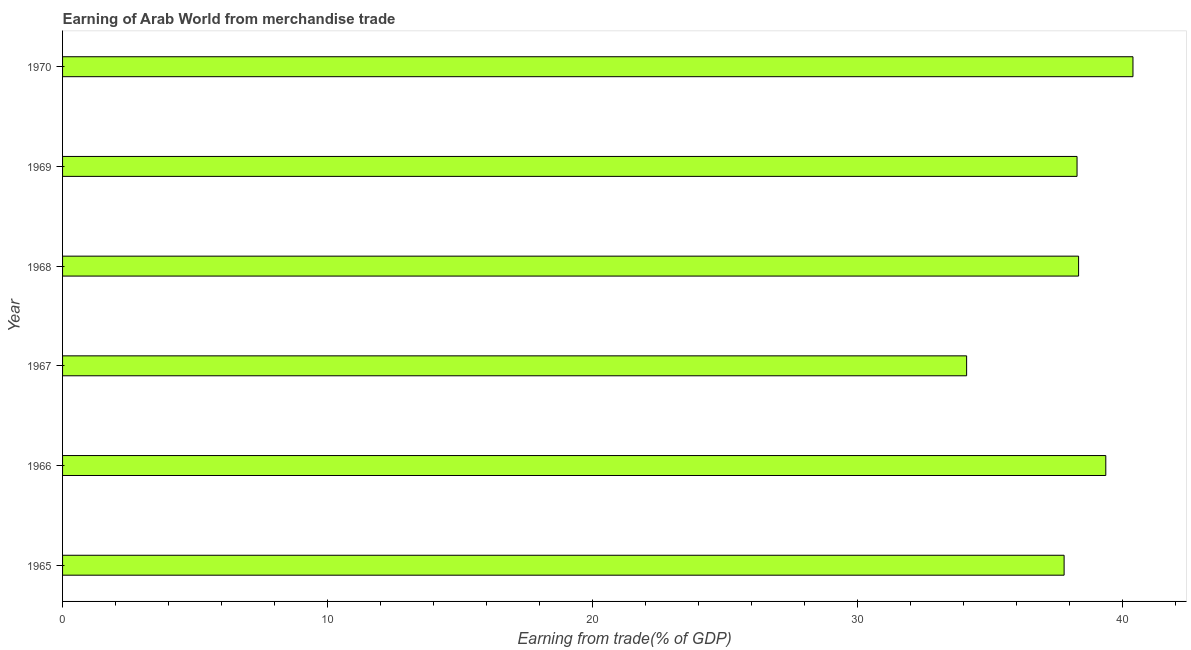Does the graph contain any zero values?
Offer a terse response. No. Does the graph contain grids?
Make the answer very short. No. What is the title of the graph?
Provide a succinct answer. Earning of Arab World from merchandise trade. What is the label or title of the X-axis?
Your answer should be compact. Earning from trade(% of GDP). What is the label or title of the Y-axis?
Your answer should be very brief. Year. What is the earning from merchandise trade in 1966?
Give a very brief answer. 39.38. Across all years, what is the maximum earning from merchandise trade?
Ensure brevity in your answer.  40.4. Across all years, what is the minimum earning from merchandise trade?
Provide a short and direct response. 34.12. In which year was the earning from merchandise trade maximum?
Your answer should be very brief. 1970. In which year was the earning from merchandise trade minimum?
Provide a succinct answer. 1967. What is the sum of the earning from merchandise trade?
Provide a succinct answer. 228.34. What is the difference between the earning from merchandise trade in 1965 and 1968?
Offer a terse response. -0.55. What is the average earning from merchandise trade per year?
Your answer should be very brief. 38.06. What is the median earning from merchandise trade?
Provide a short and direct response. 38.32. In how many years, is the earning from merchandise trade greater than 12 %?
Your response must be concise. 6. Do a majority of the years between 1965 and 1969 (inclusive) have earning from merchandise trade greater than 36 %?
Ensure brevity in your answer.  Yes. What is the ratio of the earning from merchandise trade in 1966 to that in 1968?
Offer a very short reply. 1.03. Is the difference between the earning from merchandise trade in 1966 and 1968 greater than the difference between any two years?
Keep it short and to the point. No. What is the difference between the highest and the second highest earning from merchandise trade?
Provide a short and direct response. 1.03. What is the difference between the highest and the lowest earning from merchandise trade?
Your answer should be compact. 6.28. What is the difference between two consecutive major ticks on the X-axis?
Make the answer very short. 10. Are the values on the major ticks of X-axis written in scientific E-notation?
Make the answer very short. No. What is the Earning from trade(% of GDP) of 1965?
Your response must be concise. 37.8. What is the Earning from trade(% of GDP) in 1966?
Ensure brevity in your answer.  39.38. What is the Earning from trade(% of GDP) in 1967?
Ensure brevity in your answer.  34.12. What is the Earning from trade(% of GDP) of 1968?
Offer a very short reply. 38.35. What is the Earning from trade(% of GDP) in 1969?
Provide a succinct answer. 38.29. What is the Earning from trade(% of GDP) in 1970?
Offer a terse response. 40.4. What is the difference between the Earning from trade(% of GDP) in 1965 and 1966?
Your answer should be very brief. -1.57. What is the difference between the Earning from trade(% of GDP) in 1965 and 1967?
Provide a short and direct response. 3.68. What is the difference between the Earning from trade(% of GDP) in 1965 and 1968?
Make the answer very short. -0.55. What is the difference between the Earning from trade(% of GDP) in 1965 and 1969?
Offer a very short reply. -0.49. What is the difference between the Earning from trade(% of GDP) in 1965 and 1970?
Ensure brevity in your answer.  -2.6. What is the difference between the Earning from trade(% of GDP) in 1966 and 1967?
Keep it short and to the point. 5.25. What is the difference between the Earning from trade(% of GDP) in 1966 and 1968?
Ensure brevity in your answer.  1.03. What is the difference between the Earning from trade(% of GDP) in 1966 and 1969?
Ensure brevity in your answer.  1.09. What is the difference between the Earning from trade(% of GDP) in 1966 and 1970?
Provide a succinct answer. -1.03. What is the difference between the Earning from trade(% of GDP) in 1967 and 1968?
Your answer should be compact. -4.23. What is the difference between the Earning from trade(% of GDP) in 1967 and 1969?
Provide a succinct answer. -4.17. What is the difference between the Earning from trade(% of GDP) in 1967 and 1970?
Ensure brevity in your answer.  -6.28. What is the difference between the Earning from trade(% of GDP) in 1968 and 1969?
Provide a short and direct response. 0.06. What is the difference between the Earning from trade(% of GDP) in 1968 and 1970?
Provide a succinct answer. -2.05. What is the difference between the Earning from trade(% of GDP) in 1969 and 1970?
Offer a terse response. -2.11. What is the ratio of the Earning from trade(% of GDP) in 1965 to that in 1967?
Provide a succinct answer. 1.11. What is the ratio of the Earning from trade(% of GDP) in 1965 to that in 1968?
Keep it short and to the point. 0.99. What is the ratio of the Earning from trade(% of GDP) in 1965 to that in 1970?
Offer a terse response. 0.94. What is the ratio of the Earning from trade(% of GDP) in 1966 to that in 1967?
Ensure brevity in your answer.  1.15. What is the ratio of the Earning from trade(% of GDP) in 1966 to that in 1968?
Your answer should be very brief. 1.03. What is the ratio of the Earning from trade(% of GDP) in 1966 to that in 1969?
Your response must be concise. 1.03. What is the ratio of the Earning from trade(% of GDP) in 1966 to that in 1970?
Your answer should be very brief. 0.97. What is the ratio of the Earning from trade(% of GDP) in 1967 to that in 1968?
Your response must be concise. 0.89. What is the ratio of the Earning from trade(% of GDP) in 1967 to that in 1969?
Give a very brief answer. 0.89. What is the ratio of the Earning from trade(% of GDP) in 1967 to that in 1970?
Give a very brief answer. 0.84. What is the ratio of the Earning from trade(% of GDP) in 1968 to that in 1969?
Provide a succinct answer. 1. What is the ratio of the Earning from trade(% of GDP) in 1968 to that in 1970?
Provide a short and direct response. 0.95. What is the ratio of the Earning from trade(% of GDP) in 1969 to that in 1970?
Offer a very short reply. 0.95. 